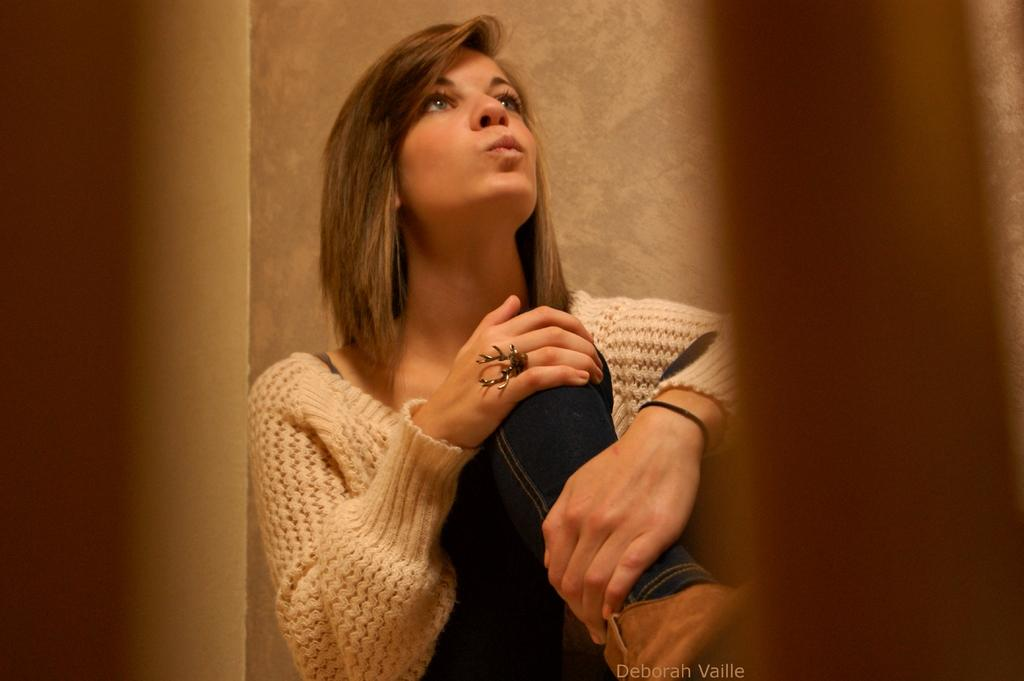What is the woman in the image doing? The woman is sitting in the image. What type of clothing is the woman wearing? The woman is wearing a sweater and a pant. What can be seen in the background of the image? There is a wall in the background of the image. What type of needle is the woman using in the image? There is no needle present in the image. What type of club is the woman holding in the image? There is no club present in the image. 